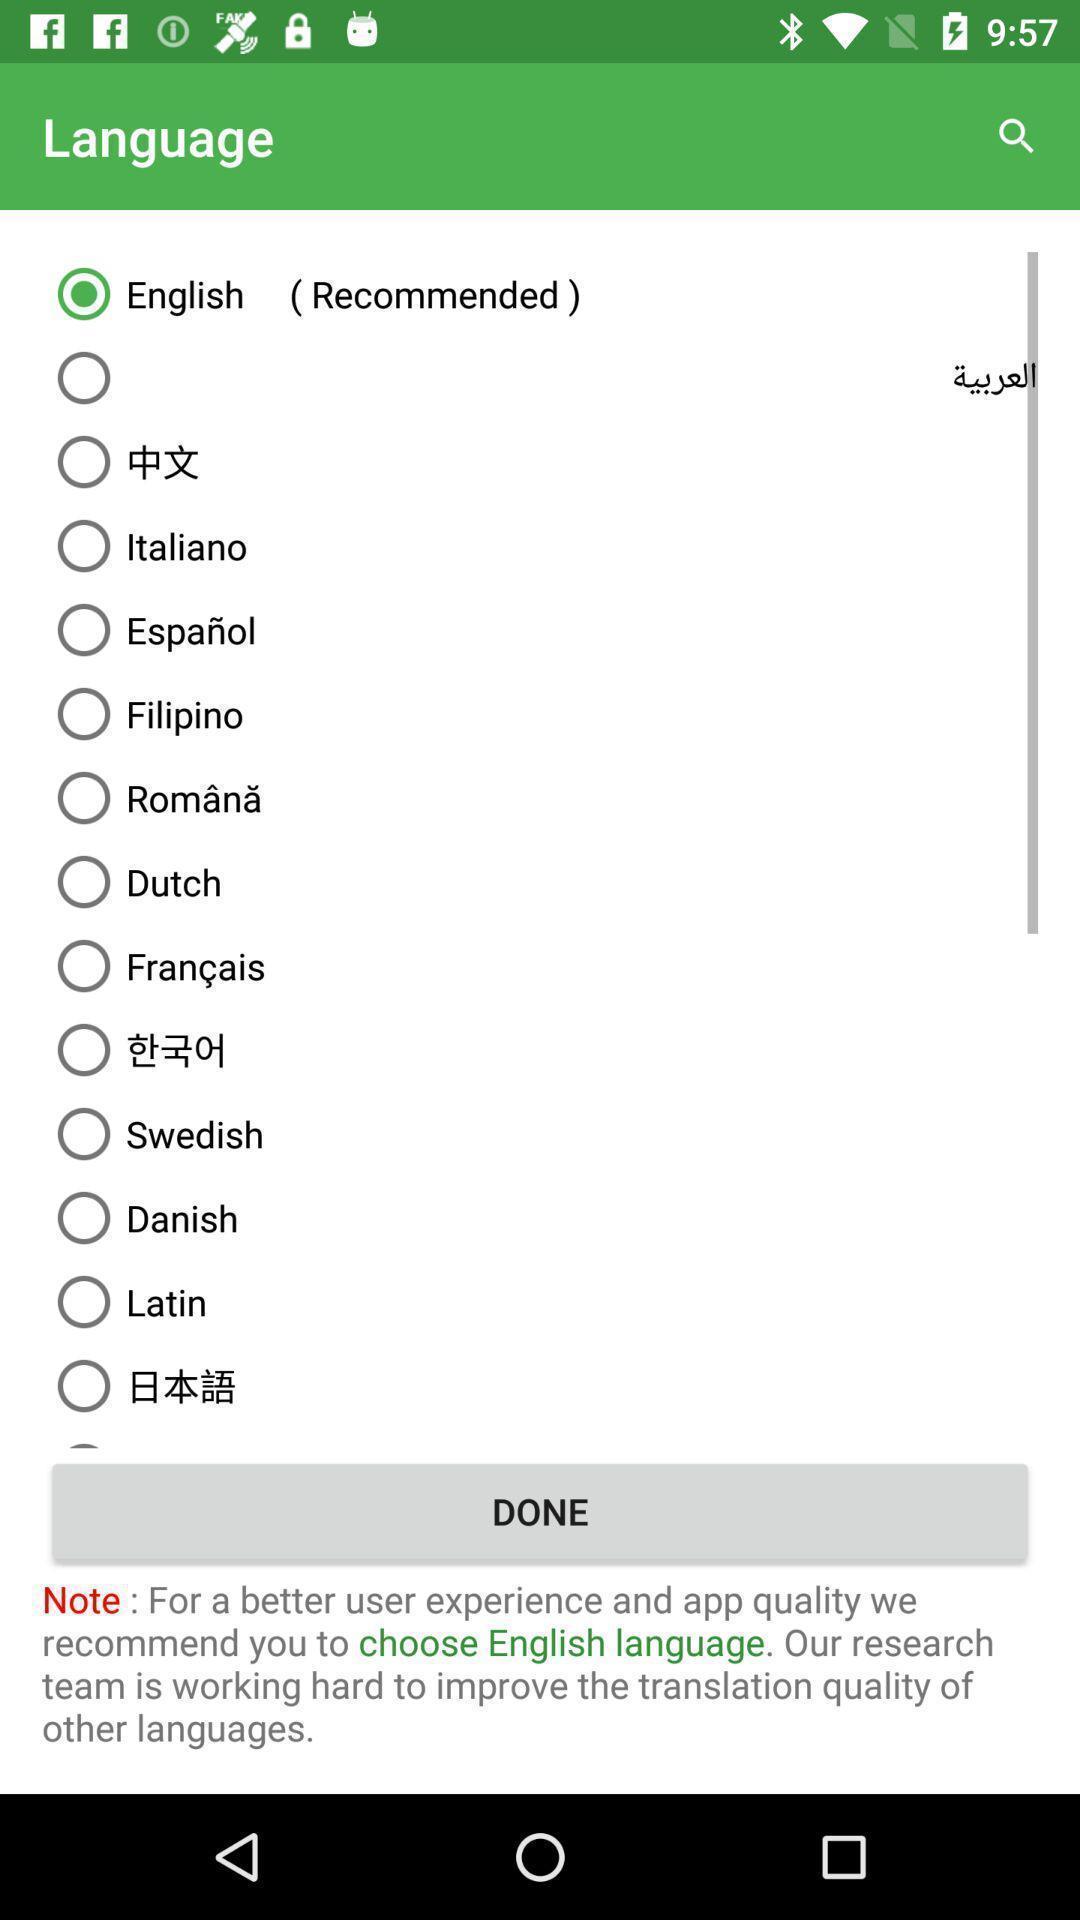Provide a detailed account of this screenshot. Screen shows to choose a language. 